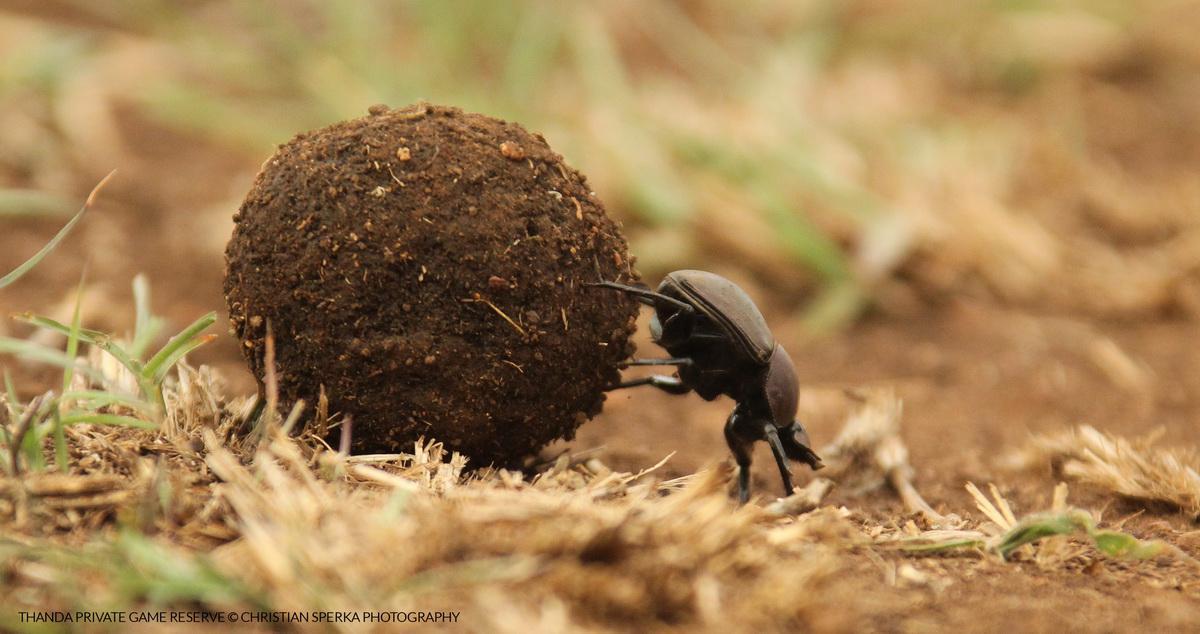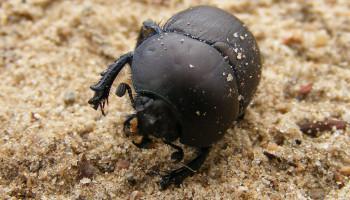The first image is the image on the left, the second image is the image on the right. For the images shown, is this caption "There are two beetles in one of the images." true? Answer yes or no. No. 